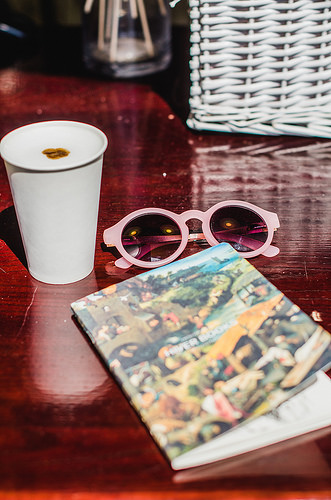<image>
Can you confirm if the sunglasses is on the book? No. The sunglasses is not positioned on the book. They may be near each other, but the sunglasses is not supported by or resting on top of the book. Where is the glass in relation to the drink? Is it next to the drink? Yes. The glass is positioned adjacent to the drink, located nearby in the same general area. Where is the sunglasses in relation to the notebook? Is it above the notebook? No. The sunglasses is not positioned above the notebook. The vertical arrangement shows a different relationship. 